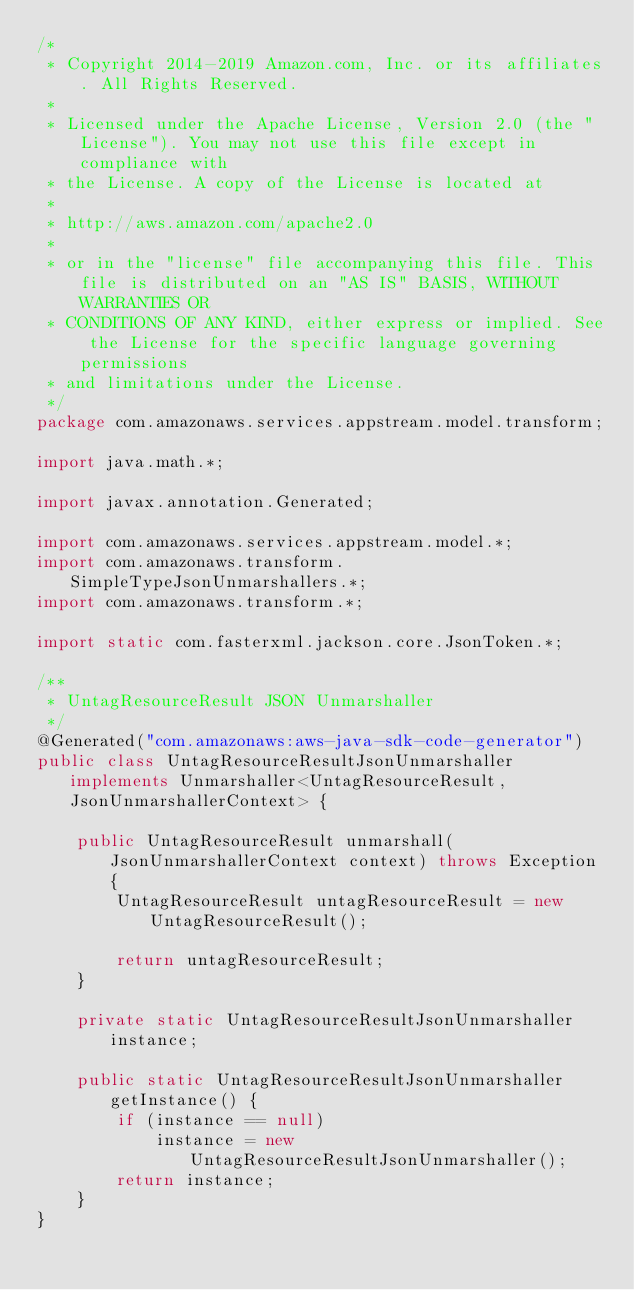<code> <loc_0><loc_0><loc_500><loc_500><_Java_>/*
 * Copyright 2014-2019 Amazon.com, Inc. or its affiliates. All Rights Reserved.
 * 
 * Licensed under the Apache License, Version 2.0 (the "License"). You may not use this file except in compliance with
 * the License. A copy of the License is located at
 * 
 * http://aws.amazon.com/apache2.0
 * 
 * or in the "license" file accompanying this file. This file is distributed on an "AS IS" BASIS, WITHOUT WARRANTIES OR
 * CONDITIONS OF ANY KIND, either express or implied. See the License for the specific language governing permissions
 * and limitations under the License.
 */
package com.amazonaws.services.appstream.model.transform;

import java.math.*;

import javax.annotation.Generated;

import com.amazonaws.services.appstream.model.*;
import com.amazonaws.transform.SimpleTypeJsonUnmarshallers.*;
import com.amazonaws.transform.*;

import static com.fasterxml.jackson.core.JsonToken.*;

/**
 * UntagResourceResult JSON Unmarshaller
 */
@Generated("com.amazonaws:aws-java-sdk-code-generator")
public class UntagResourceResultJsonUnmarshaller implements Unmarshaller<UntagResourceResult, JsonUnmarshallerContext> {

    public UntagResourceResult unmarshall(JsonUnmarshallerContext context) throws Exception {
        UntagResourceResult untagResourceResult = new UntagResourceResult();

        return untagResourceResult;
    }

    private static UntagResourceResultJsonUnmarshaller instance;

    public static UntagResourceResultJsonUnmarshaller getInstance() {
        if (instance == null)
            instance = new UntagResourceResultJsonUnmarshaller();
        return instance;
    }
}
</code> 